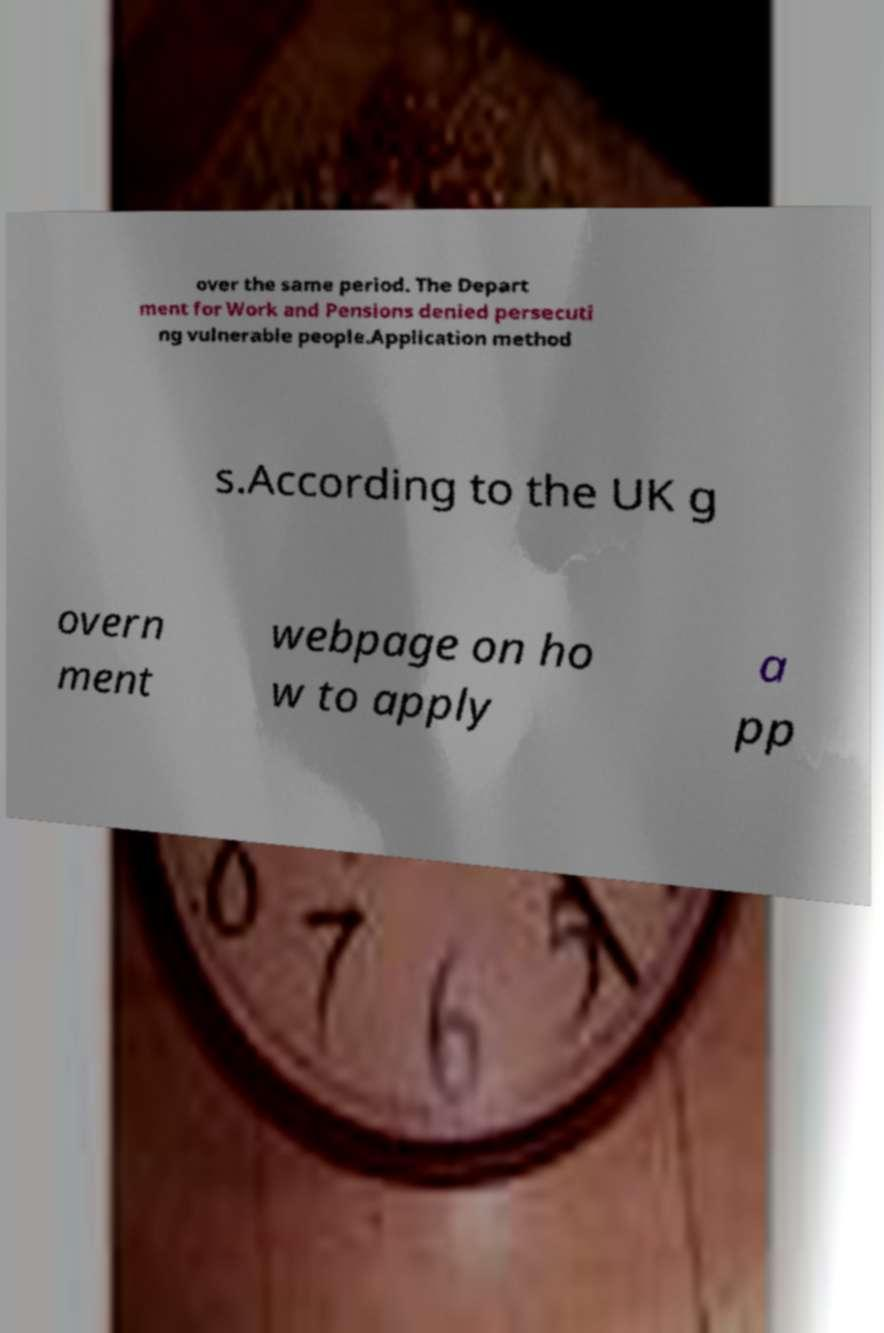Please identify and transcribe the text found in this image. over the same period. The Depart ment for Work and Pensions denied persecuti ng vulnerable people.Application method s.According to the UK g overn ment webpage on ho w to apply a pp 